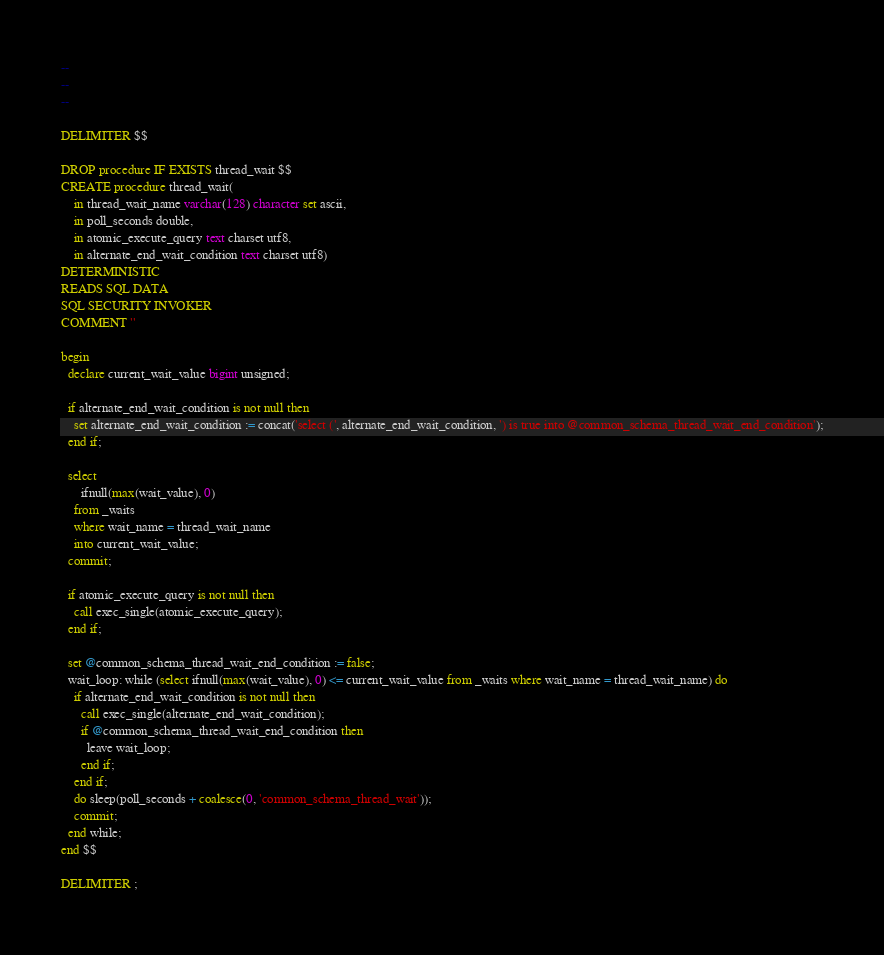Convert code to text. <code><loc_0><loc_0><loc_500><loc_500><_SQL_>-- 
-- 
-- 

DELIMITER $$

DROP procedure IF EXISTS thread_wait $$
CREATE procedure thread_wait(
    in thread_wait_name varchar(128) character set ascii, 
    in poll_seconds double,
    in atomic_execute_query text charset utf8,
    in alternate_end_wait_condition text charset utf8)
DETERMINISTIC
READS SQL DATA
SQL SECURITY INVOKER
COMMENT ''

begin
  declare current_wait_value bigint unsigned;
  
  if alternate_end_wait_condition is not null then
  	set alternate_end_wait_condition := concat('select (', alternate_end_wait_condition, ') is true into @common_schema_thread_wait_end_condition');
  end if;
  
  select 
      ifnull(max(wait_value), 0) 
    from _waits 
    where wait_name = thread_wait_name 
    into current_wait_value;
  commit;
  
  if atomic_execute_query is not null then
  	call exec_single(atomic_execute_query);
  end if;
  
  set @common_schema_thread_wait_end_condition := false;
  wait_loop: while (select ifnull(max(wait_value), 0) <= current_wait_value from _waits where wait_name = thread_wait_name) do
    if alternate_end_wait_condition is not null then
      call exec_single(alternate_end_wait_condition);
      if @common_schema_thread_wait_end_condition then
        leave wait_loop;
      end if;
    end if;  
    do sleep(poll_seconds + coalesce(0, 'common_schema_thread_wait'));
    commit;
  end while;
end $$

DELIMITER ;
</code> 